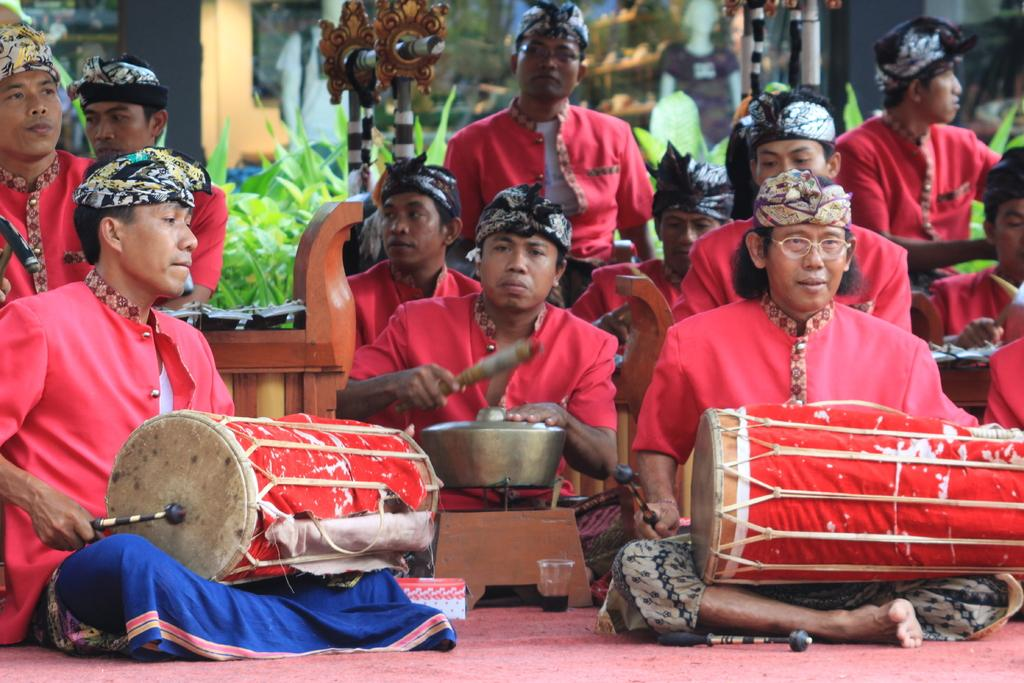What are the people in the image doing? The people in the image are playing drums. What are the people wearing while playing drums? The people are wearing red costumes. Can you describe any furniture in the image? There is a wooden chair in the background of the image. What can be seen in the distance behind the people? Trees are visible in the background of the image. Where is the heart-shaped camp located in the image? There is no heart-shaped camp present in the image. Can you tell me the name of the aunt who is playing the drums in the image? There is no mention of an aunt in the image; the people playing drums are not identified by name or relation. 